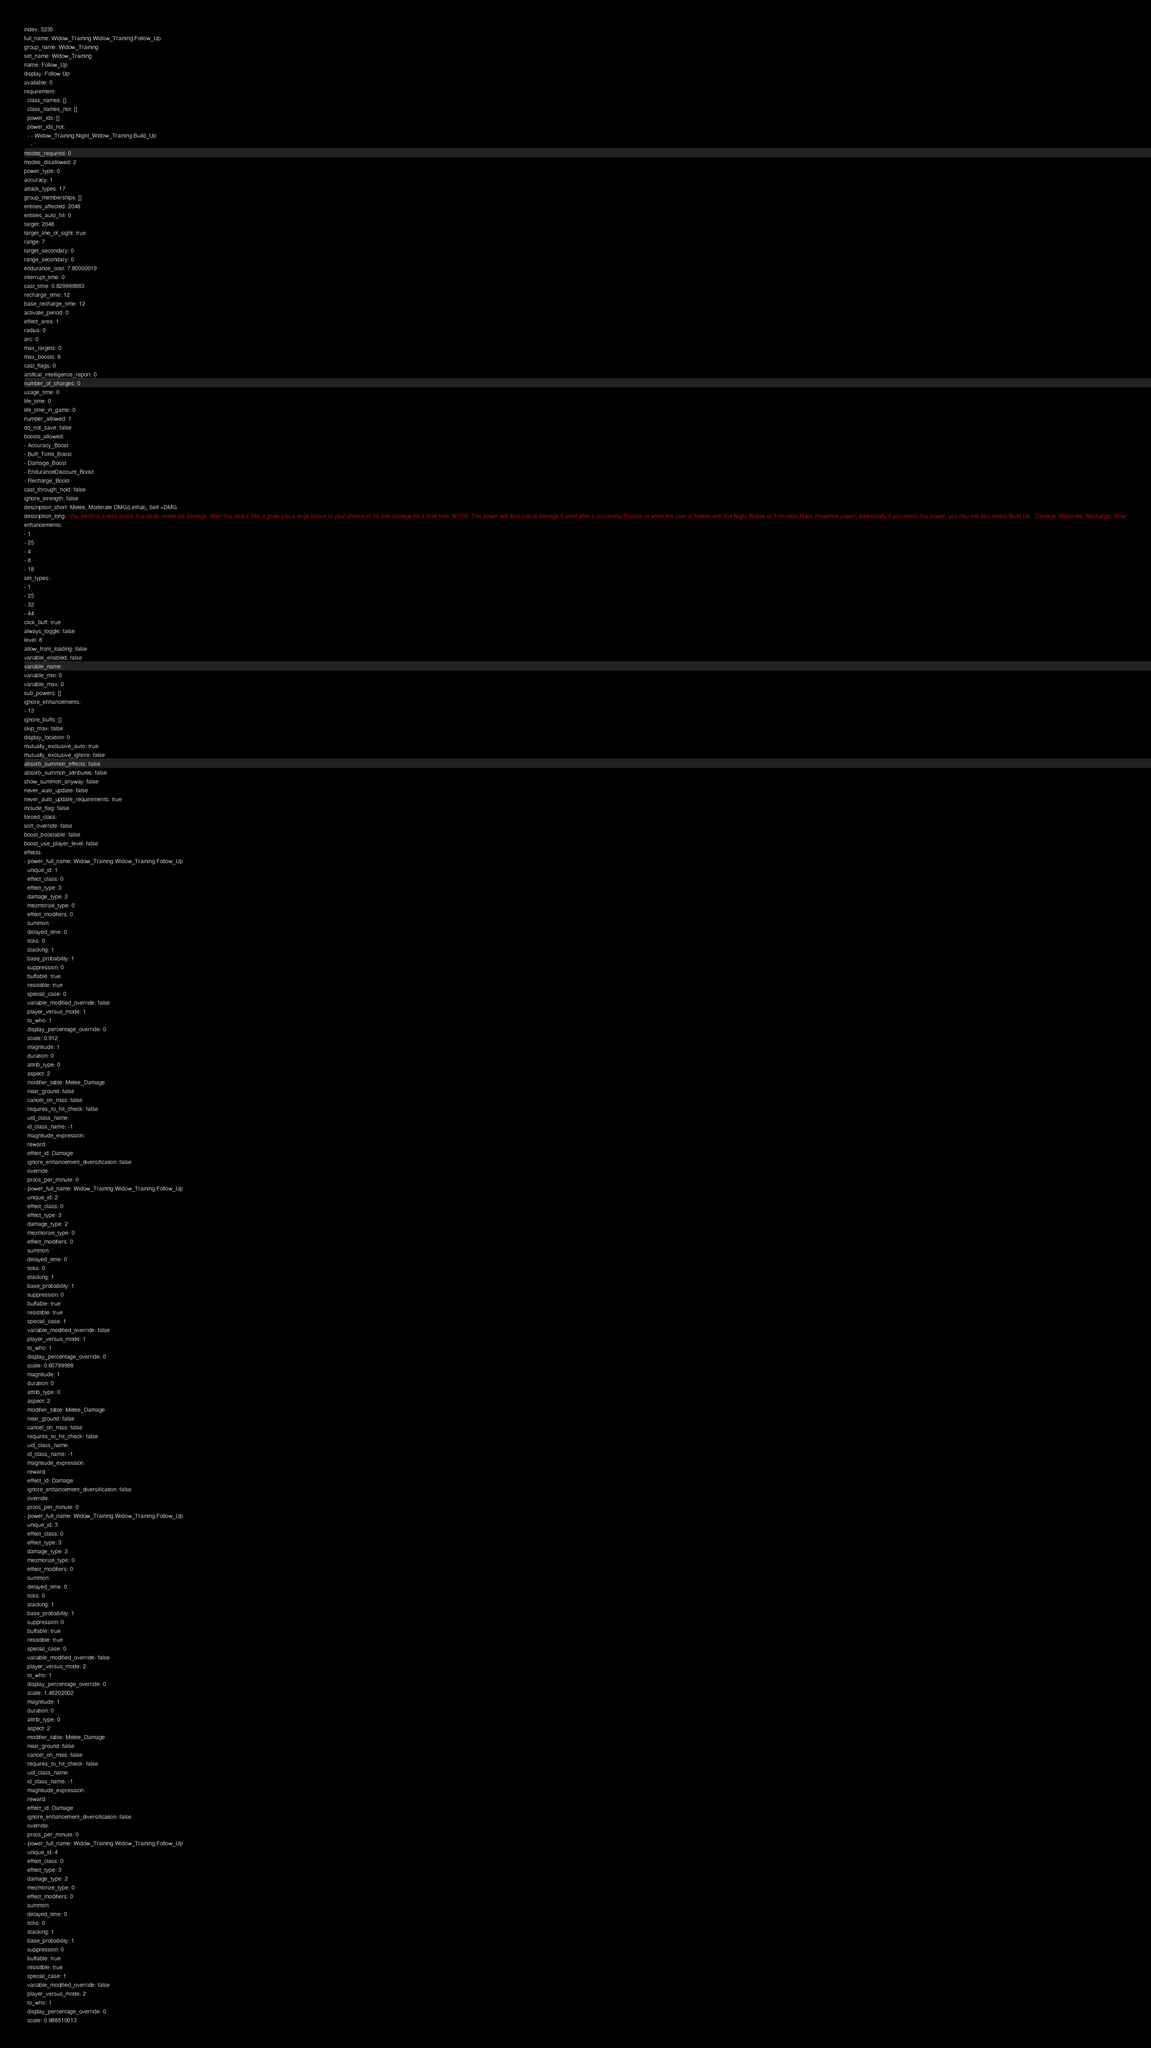Convert code to text. <code><loc_0><loc_0><loc_500><loc_500><_YAML_>index: 3235
full_name: Widow_Training.Widow_Training.Follow_Up
group_name: Widow_Training
set_name: Widow_Training
name: Follow_Up
display: Follow Up
available: 0
requirement:
  class_names: []
  class_names_not: []
  power_ids: []
  power_ids_not:
  - - Widow_Training.Night_Widow_Training.Build_Up
    - ''
modes_required: 0
modes_disallowed: 2
power_type: 0
accuracy: 1
attack_types: 17
group_memberships: []
entities_affected: 2048
entities_auto_hit: 0
target: 2048
target_line_of_sight: true
range: 7
target_secondary: 0
range_secondary: 0
endurance_cost: 7.80000019
interrupt_time: 0
cast_time: 0.829999983
recharge_time: 12
base_recharge_time: 12
activate_period: 0
effect_area: 1
radius: 0
arc: 0
max_targets: 0
max_boosts: 6
cast_flags: 0
artifical_intelligence_report: 0
number_of_charges: 0
usage_time: 0
life_time: 0
life_time_in_game: 0
number_allowed: 1
do_not_save: false
boosts_allowed:
- Accuracy_Boost
- Buff_ToHit_Boost
- Damage_Boost
- EnduranceDiscount_Boost
- Recharge_Boost
cast_through_hold: false
ignore_strength: false
description_short: Melee, Moderate DMG(Lethal), Self +DMG
description_long: 'You perform a feint attack that deals moderate damage. After this attack hits, it gives you a large bonus to your chance to hit and damage for a brief time. NOTE: This power will deal critical damage if used after a successful Placate or while the user is hidden with the Night Widow or Fortunata Mask Presence power, additionally if you select this power, you may not also select Build Up.  Damage: Moderate, Recharge: Slow'
enhancements:
- 1
- 25
- 4
- 8
- 18
set_types:
- 1
- 25
- 32
- 44
click_buff: true
always_toggle: false
level: 8
allow_front_loading: false
variable_enabled: false
variable_name: ''
variable_min: 0
variable_max: 0
sub_powers: []
ignore_enhancements:
- 13
ignore_buffs: []
skip_max: false
display_location: 0
mutually_exclusive_auto: true
mutually_exclusive_ignore: false
absorb_summon_effects: false
absorb_summon_attributes: false
show_summon_anyway: false
never_auto_update: false
never_auto_update_requirements: true
include_flag: false
forced_class: ''
sort_override: false
boost_boostable: false
boost_use_player_level: false
effects:
- power_full_name: Widow_Training.Widow_Training.Follow_Up
  unique_id: 1
  effect_class: 0
  effect_type: 3
  damage_type: 2
  mezmorize_type: 0
  effect_modifiers: 0
  summon: ''
  delayed_time: 0
  ticks: 0
  stacking: 1
  base_probability: 1
  suppression: 0
  buffable: true
  resistible: true
  special_case: 0
  variable_modified_override: false
  player_versus_mode: 1
  to_who: 1
  display_percentage_override: 0
  scale: 0.912
  magnitude: 1
  duration: 0
  attrib_type: 0
  aspect: 2
  modifier_table: Melee_Damage
  near_ground: false
  cancel_on_miss: false
  requires_to_hit_check: false
  uid_class_name: ''
  id_class_name: -1
  magnitude_expression: ''
  reward: ''
  effect_id: Damage
  ignore_enhancement_diversification: false
  override: ''
  procs_per_minute: 0
- power_full_name: Widow_Training.Widow_Training.Follow_Up
  unique_id: 2
  effect_class: 0
  effect_type: 3
  damage_type: 2
  mezmorize_type: 0
  effect_modifiers: 0
  summon: ''
  delayed_time: 0
  ticks: 0
  stacking: 1
  base_probability: 1
  suppression: 0
  buffable: true
  resistible: true
  special_case: 1
  variable_modified_override: false
  player_versus_mode: 1
  to_who: 1
  display_percentage_override: 0
  scale: 0.60799998
  magnitude: 1
  duration: 0
  attrib_type: 0
  aspect: 2
  modifier_table: Melee_Damage
  near_ground: false
  cancel_on_miss: false
  requires_to_hit_check: false
  uid_class_name: ''
  id_class_name: -1
  magnitude_expression: ''
  reward: ''
  effect_id: Damage
  ignore_enhancement_diversification: false
  override: ''
  procs_per_minute: 0
- power_full_name: Widow_Training.Widow_Training.Follow_Up
  unique_id: 3
  effect_class: 0
  effect_type: 3
  damage_type: 2
  mezmorize_type: 0
  effect_modifiers: 0
  summon: ''
  delayed_time: 0
  ticks: 0
  stacking: 1
  base_probability: 1
  suppression: 0
  buffable: true
  resistible: true
  special_case: 0
  variable_modified_override: false
  player_versus_mode: 2
  to_who: 1
  display_percentage_override: 0
  scale: 1.48202002
  magnitude: 1
  duration: 0
  attrib_type: 0
  aspect: 2
  modifier_table: Melee_Damage
  near_ground: false
  cancel_on_miss: false
  requires_to_hit_check: false
  uid_class_name: ''
  id_class_name: -1
  magnitude_expression: ''
  reward: ''
  effect_id: Damage
  ignore_enhancement_diversification: false
  override: ''
  procs_per_minute: 0
- power_full_name: Widow_Training.Widow_Training.Follow_Up
  unique_id: 4
  effect_class: 0
  effect_type: 3
  damage_type: 2
  mezmorize_type: 0
  effect_modifiers: 0
  summon: ''
  delayed_time: 0
  ticks: 0
  stacking: 1
  base_probability: 1
  suppression: 0
  buffable: true
  resistible: true
  special_case: 1
  variable_modified_override: false
  player_versus_mode: 2
  to_who: 1
  display_percentage_override: 0
  scale: 0.988510013</code> 